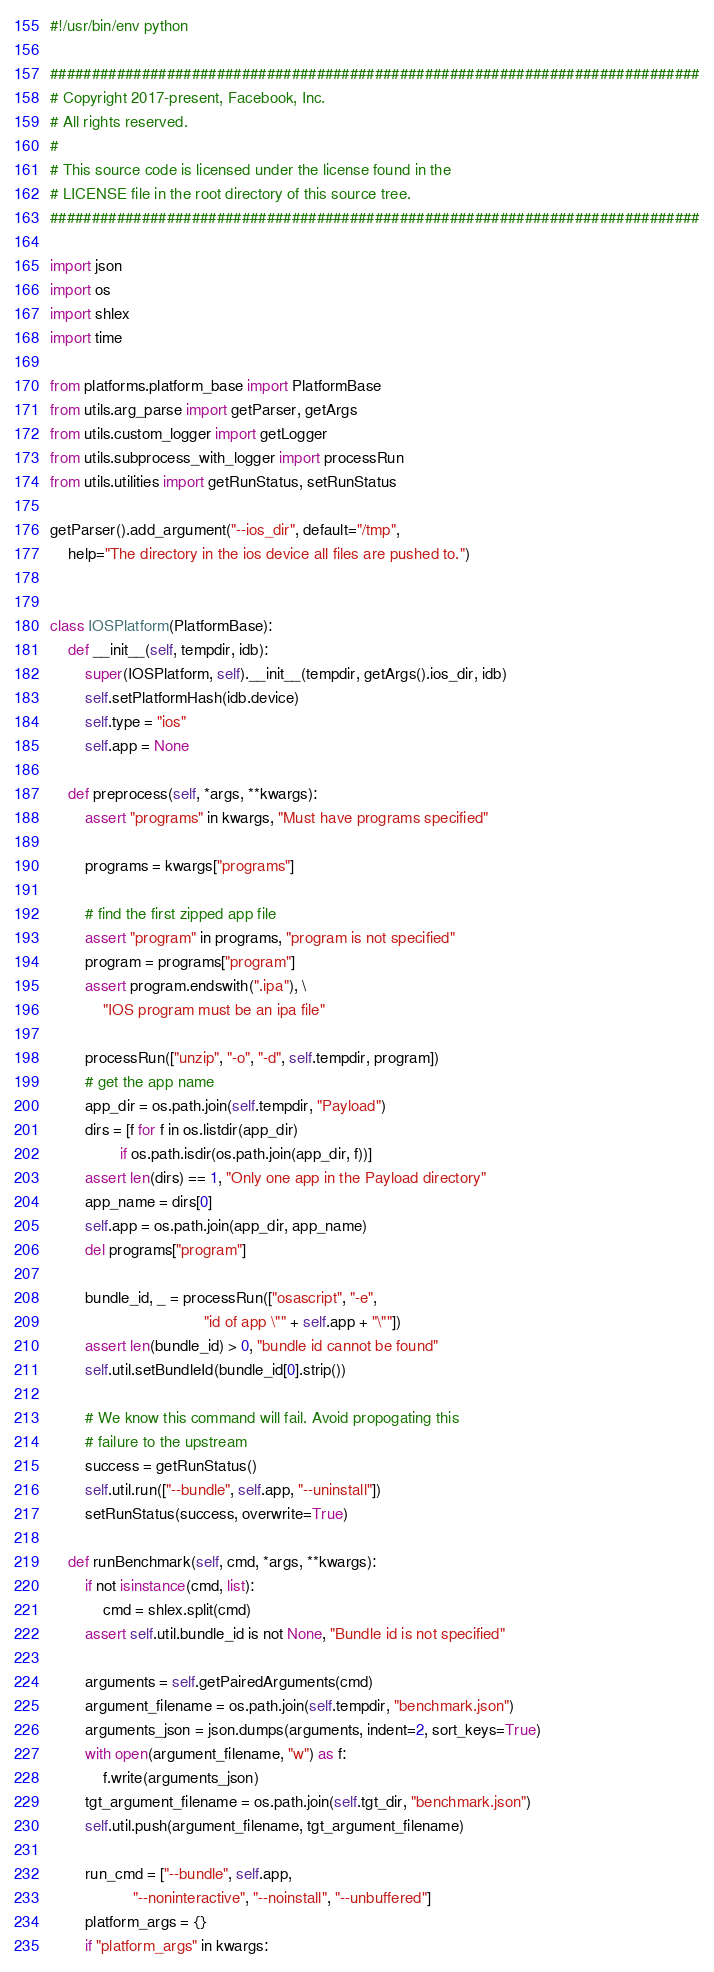<code> <loc_0><loc_0><loc_500><loc_500><_Python_>#!/usr/bin/env python

##############################################################################
# Copyright 2017-present, Facebook, Inc.
# All rights reserved.
#
# This source code is licensed under the license found in the
# LICENSE file in the root directory of this source tree.
##############################################################################

import json
import os
import shlex
import time

from platforms.platform_base import PlatformBase
from utils.arg_parse import getParser, getArgs
from utils.custom_logger import getLogger
from utils.subprocess_with_logger import processRun
from utils.utilities import getRunStatus, setRunStatus

getParser().add_argument("--ios_dir", default="/tmp",
    help="The directory in the ios device all files are pushed to.")


class IOSPlatform(PlatformBase):
    def __init__(self, tempdir, idb):
        super(IOSPlatform, self).__init__(tempdir, getArgs().ios_dir, idb)
        self.setPlatformHash(idb.device)
        self.type = "ios"
        self.app = None

    def preprocess(self, *args, **kwargs):
        assert "programs" in kwargs, "Must have programs specified"

        programs = kwargs["programs"]

        # find the first zipped app file
        assert "program" in programs, "program is not specified"
        program = programs["program"]
        assert program.endswith(".ipa"), \
            "IOS program must be an ipa file"

        processRun(["unzip", "-o", "-d", self.tempdir, program])
        # get the app name
        app_dir = os.path.join(self.tempdir, "Payload")
        dirs = [f for f in os.listdir(app_dir)
                if os.path.isdir(os.path.join(app_dir, f))]
        assert len(dirs) == 1, "Only one app in the Payload directory"
        app_name = dirs[0]
        self.app = os.path.join(app_dir, app_name)
        del programs["program"]

        bundle_id, _ = processRun(["osascript", "-e",
                                   "id of app \"" + self.app + "\""])
        assert len(bundle_id) > 0, "bundle id cannot be found"
        self.util.setBundleId(bundle_id[0].strip())

        # We know this command will fail. Avoid propogating this
        # failure to the upstream
        success = getRunStatus()
        self.util.run(["--bundle", self.app, "--uninstall"])
        setRunStatus(success, overwrite=True)

    def runBenchmark(self, cmd, *args, **kwargs):
        if not isinstance(cmd, list):
            cmd = shlex.split(cmd)
        assert self.util.bundle_id is not None, "Bundle id is not specified"

        arguments = self.getPairedArguments(cmd)
        argument_filename = os.path.join(self.tempdir, "benchmark.json")
        arguments_json = json.dumps(arguments, indent=2, sort_keys=True)
        with open(argument_filename, "w") as f:
            f.write(arguments_json)
        tgt_argument_filename = os.path.join(self.tgt_dir, "benchmark.json")
        self.util.push(argument_filename, tgt_argument_filename)

        run_cmd = ["--bundle", self.app,
                   "--noninteractive", "--noinstall", "--unbuffered"]
        platform_args = {}
        if "platform_args" in kwargs:</code> 